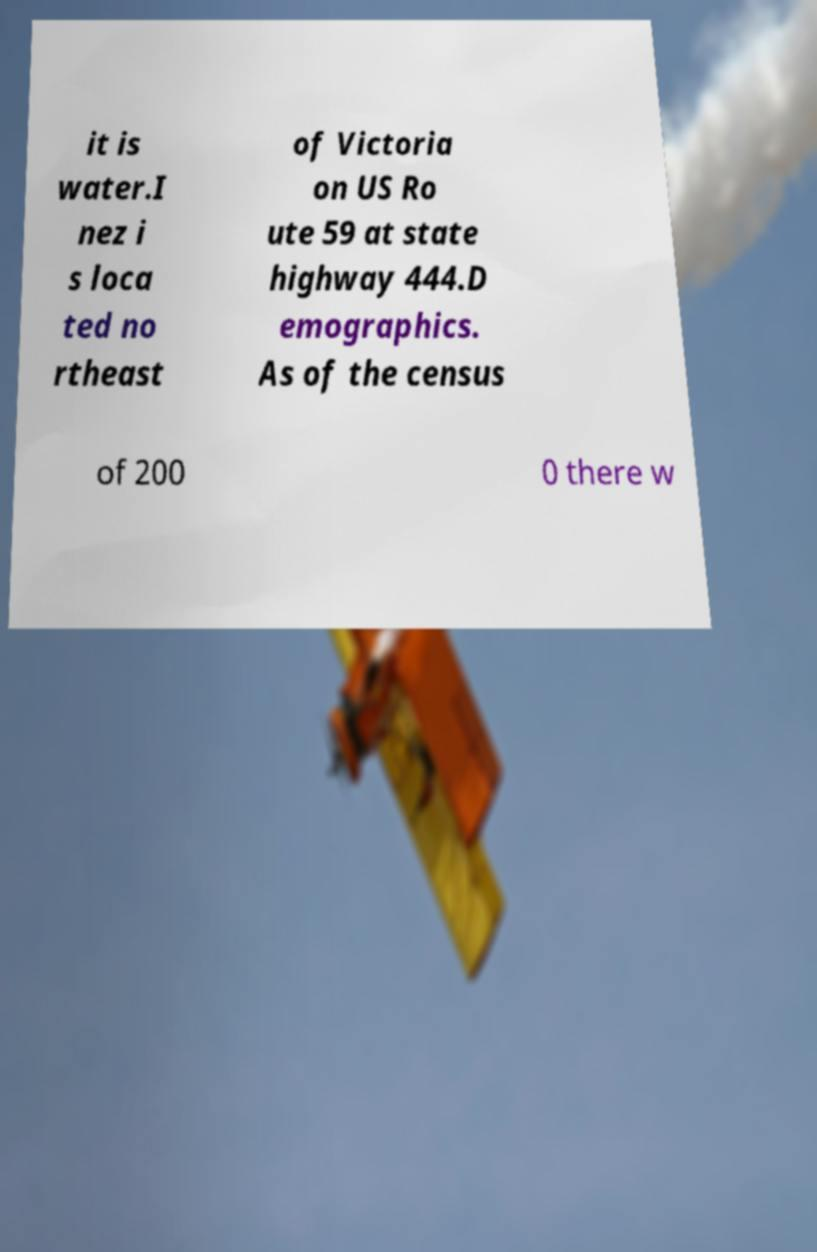Can you accurately transcribe the text from the provided image for me? it is water.I nez i s loca ted no rtheast of Victoria on US Ro ute 59 at state highway 444.D emographics. As of the census of 200 0 there w 